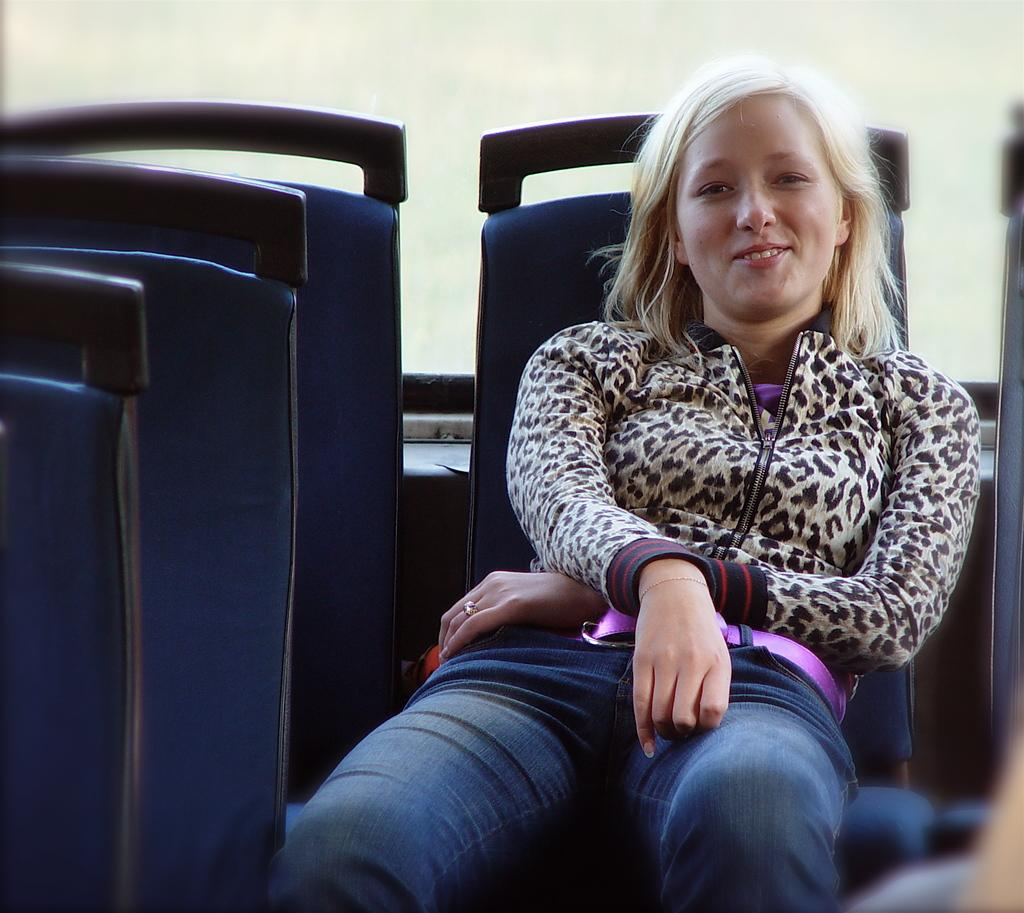Who is the main subject in the image? There is a girl in the image. What is the girl doing in the image? The girl is sitting on a seat. What is the girl wearing on her upper body? The girl is wearing a tiger print jacket. What type of pants is the girl wearing? The girl is wearing jeans. Can you tell me what type of door is visible in the image? There is no door present in the image; it features a girl sitting on a seat. What kind of argument is the girl having with the wren in the image? There is no wren present in the image, and therefore no argument can be observed. 